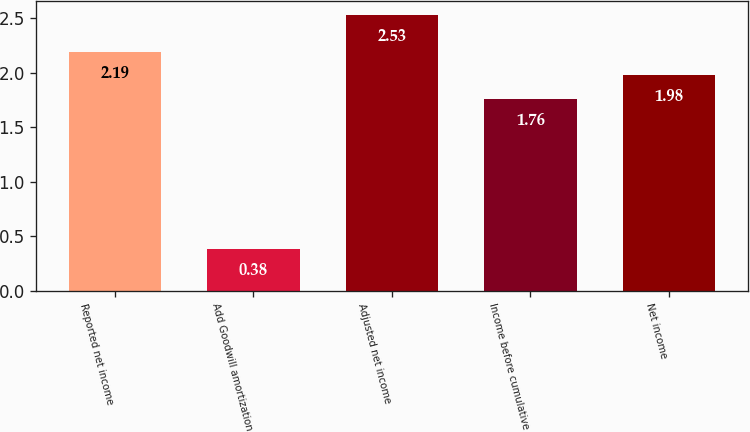Convert chart. <chart><loc_0><loc_0><loc_500><loc_500><bar_chart><fcel>Reported net income<fcel>Add Goodwill amortization<fcel>Adjusted net income<fcel>Income before cumulative<fcel>Net income<nl><fcel>2.19<fcel>0.38<fcel>2.53<fcel>1.76<fcel>1.98<nl></chart> 